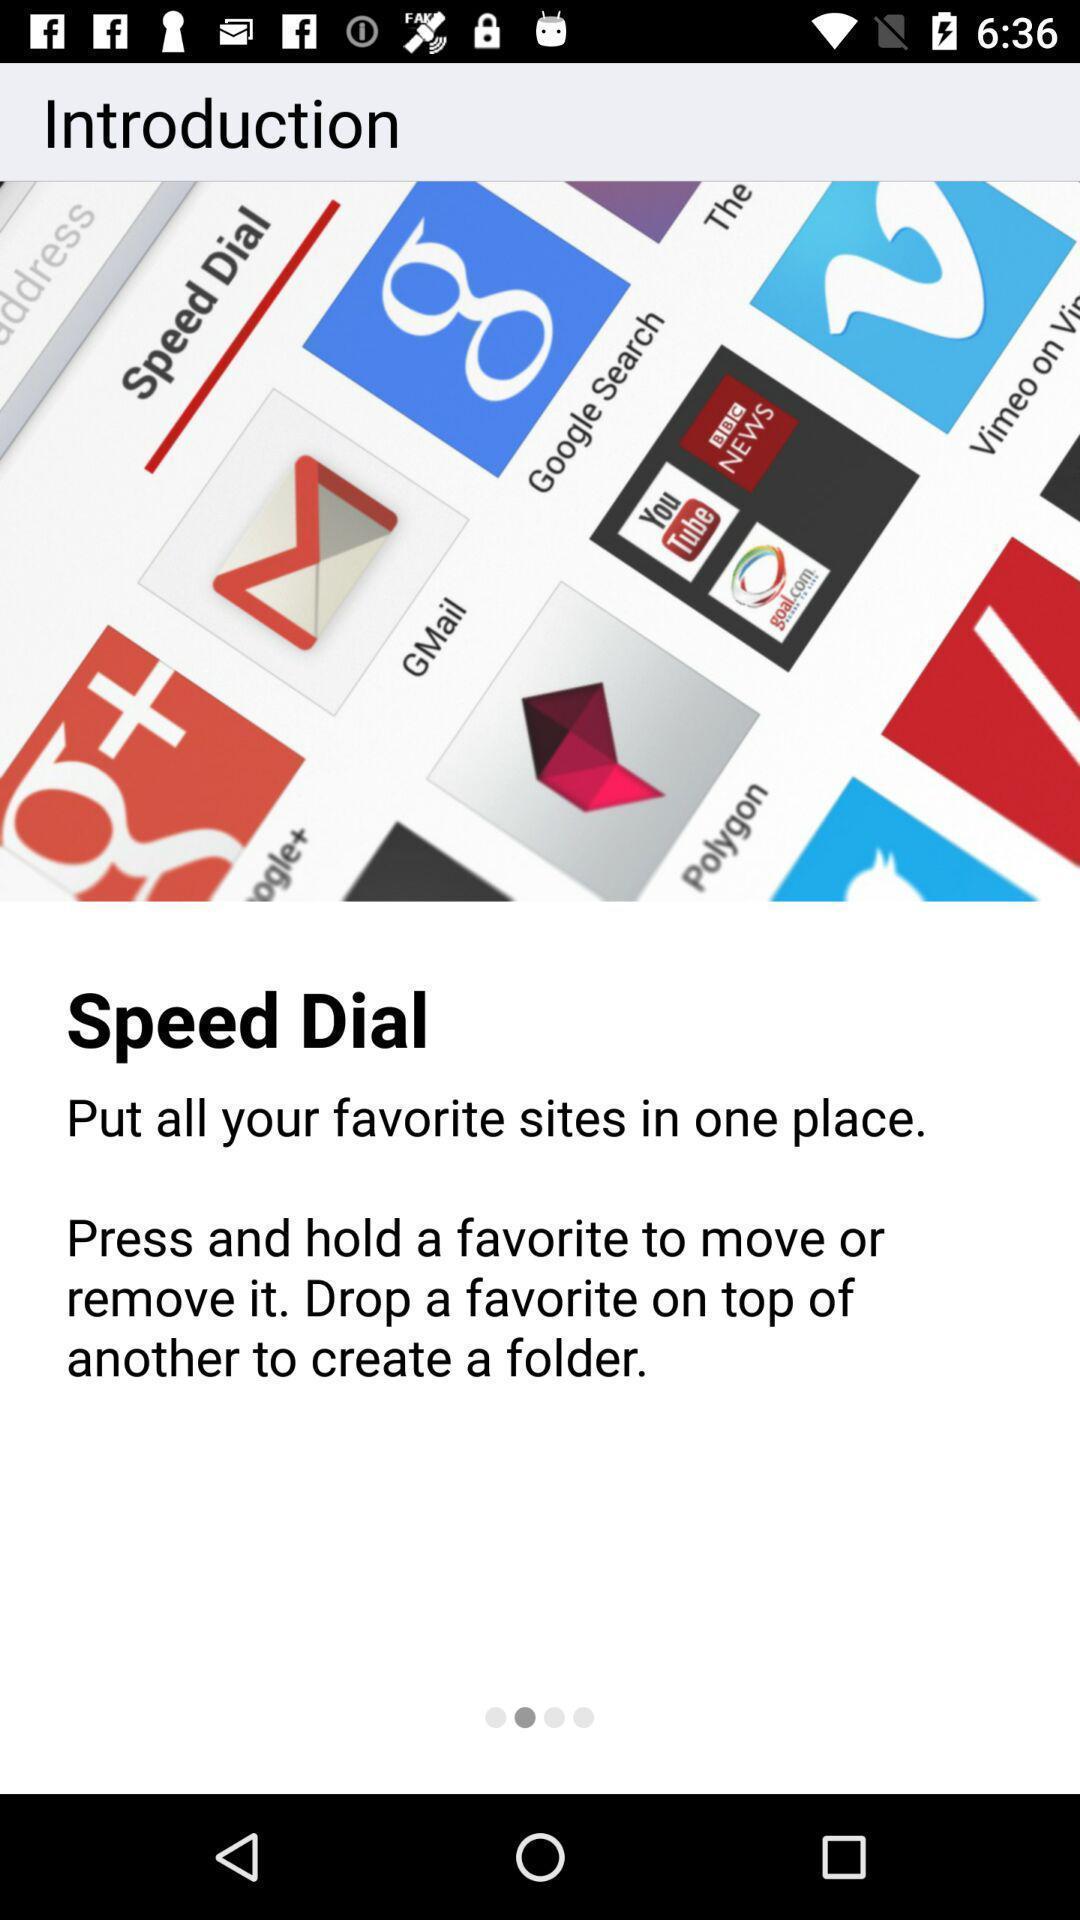Tell me about the visual elements in this screen capture. Introductory page. 